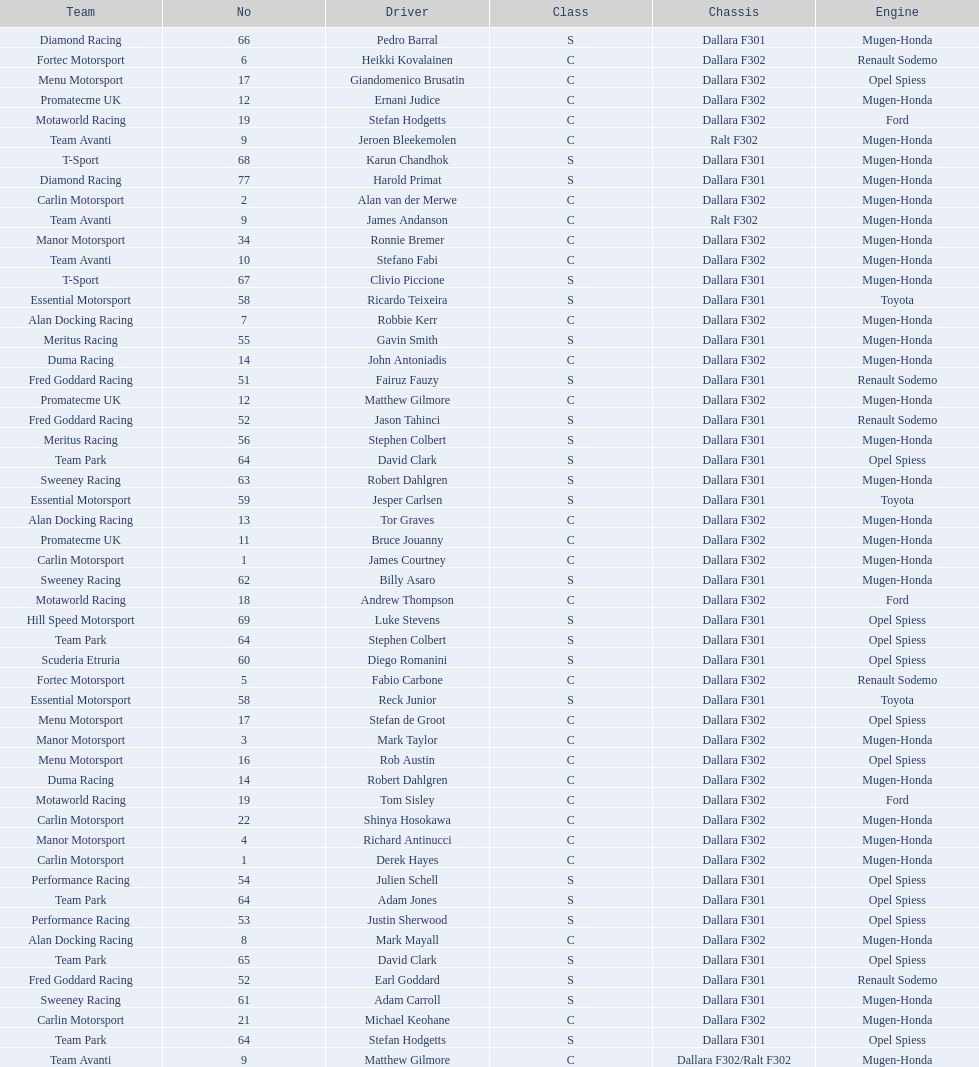What team is listed above diamond racing? Team Park. 